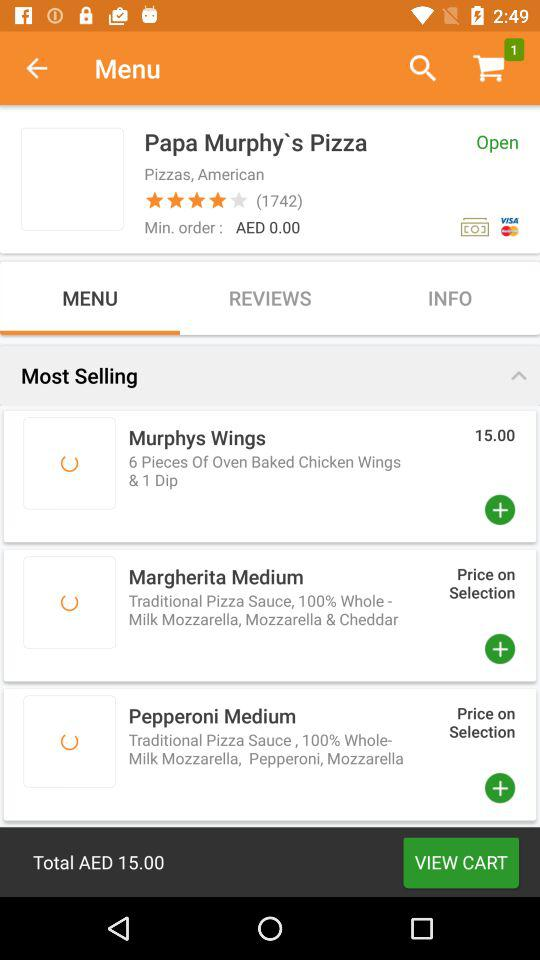What is the price of "Murphys Wings" in AED? The price of "Murphys Wings" is AED 15.00. 